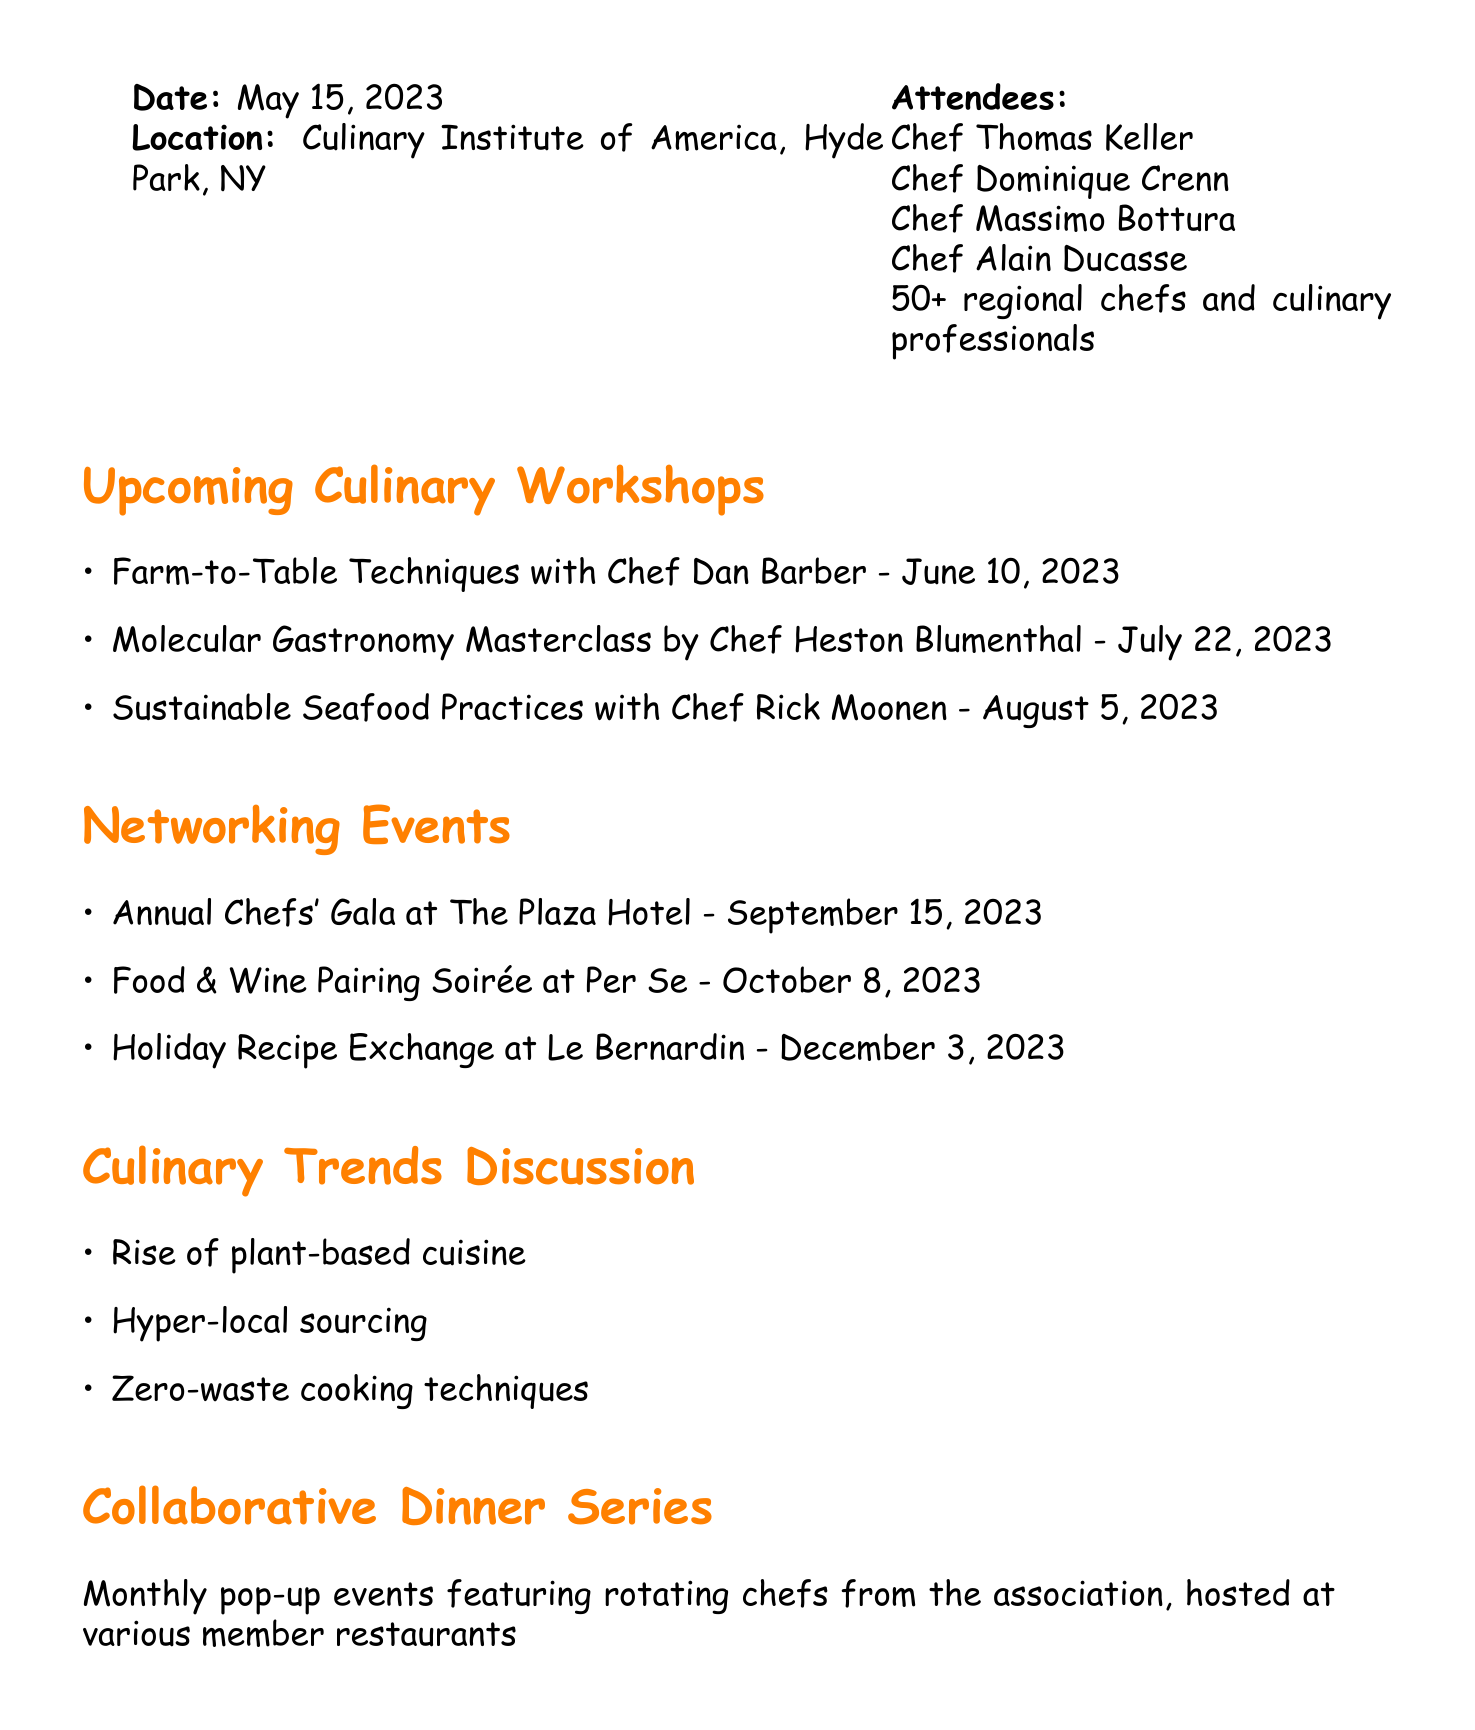What date is the gathering? The date is stated in the document as May 15, 2023.
Answer: May 15, 2023 Who is presenting the Molecular Gastronomy Masterclass? This information is found in the upcoming culinary workshops section, which lists Chef Heston Blumenthal as the presenter.
Answer: Chef Heston Blumenthal What is the location of the next meeting? The document mentions that the next meeting will be at The French Laundry, Yountville, CA.
Answer: The French Laundry, Yountville, CA How many networking events are listed? By counting the items in the networking events section, there are three events mentioned.
Answer: 3 When do attendees need to register for workshops? The document specifies the registration deadline for the workshops as May 31, 2023.
Answer: May 31, 2023 What culinary trend is mentioned in the discussion? The document lists "Rise of plant-based cuisine" as one of the culinary trends discussed.
Answer: Rise of plant-based cuisine What type of event features rotating chefs from the association? This is described as a "Collaborative Dinner Series" in the document.
Answer: Collaborative Dinner Series How many chefs attended the gathering? The document states that there were 50+ regional chefs and culinary professionals, indicating a count of "50 plus."
Answer: 50+ What is the action item related to proposals for the Collaborative Dinner Series? It states that proposals must be submitted by a specific deadline, which is June 15, 2023.
Answer: June 15, 2023 